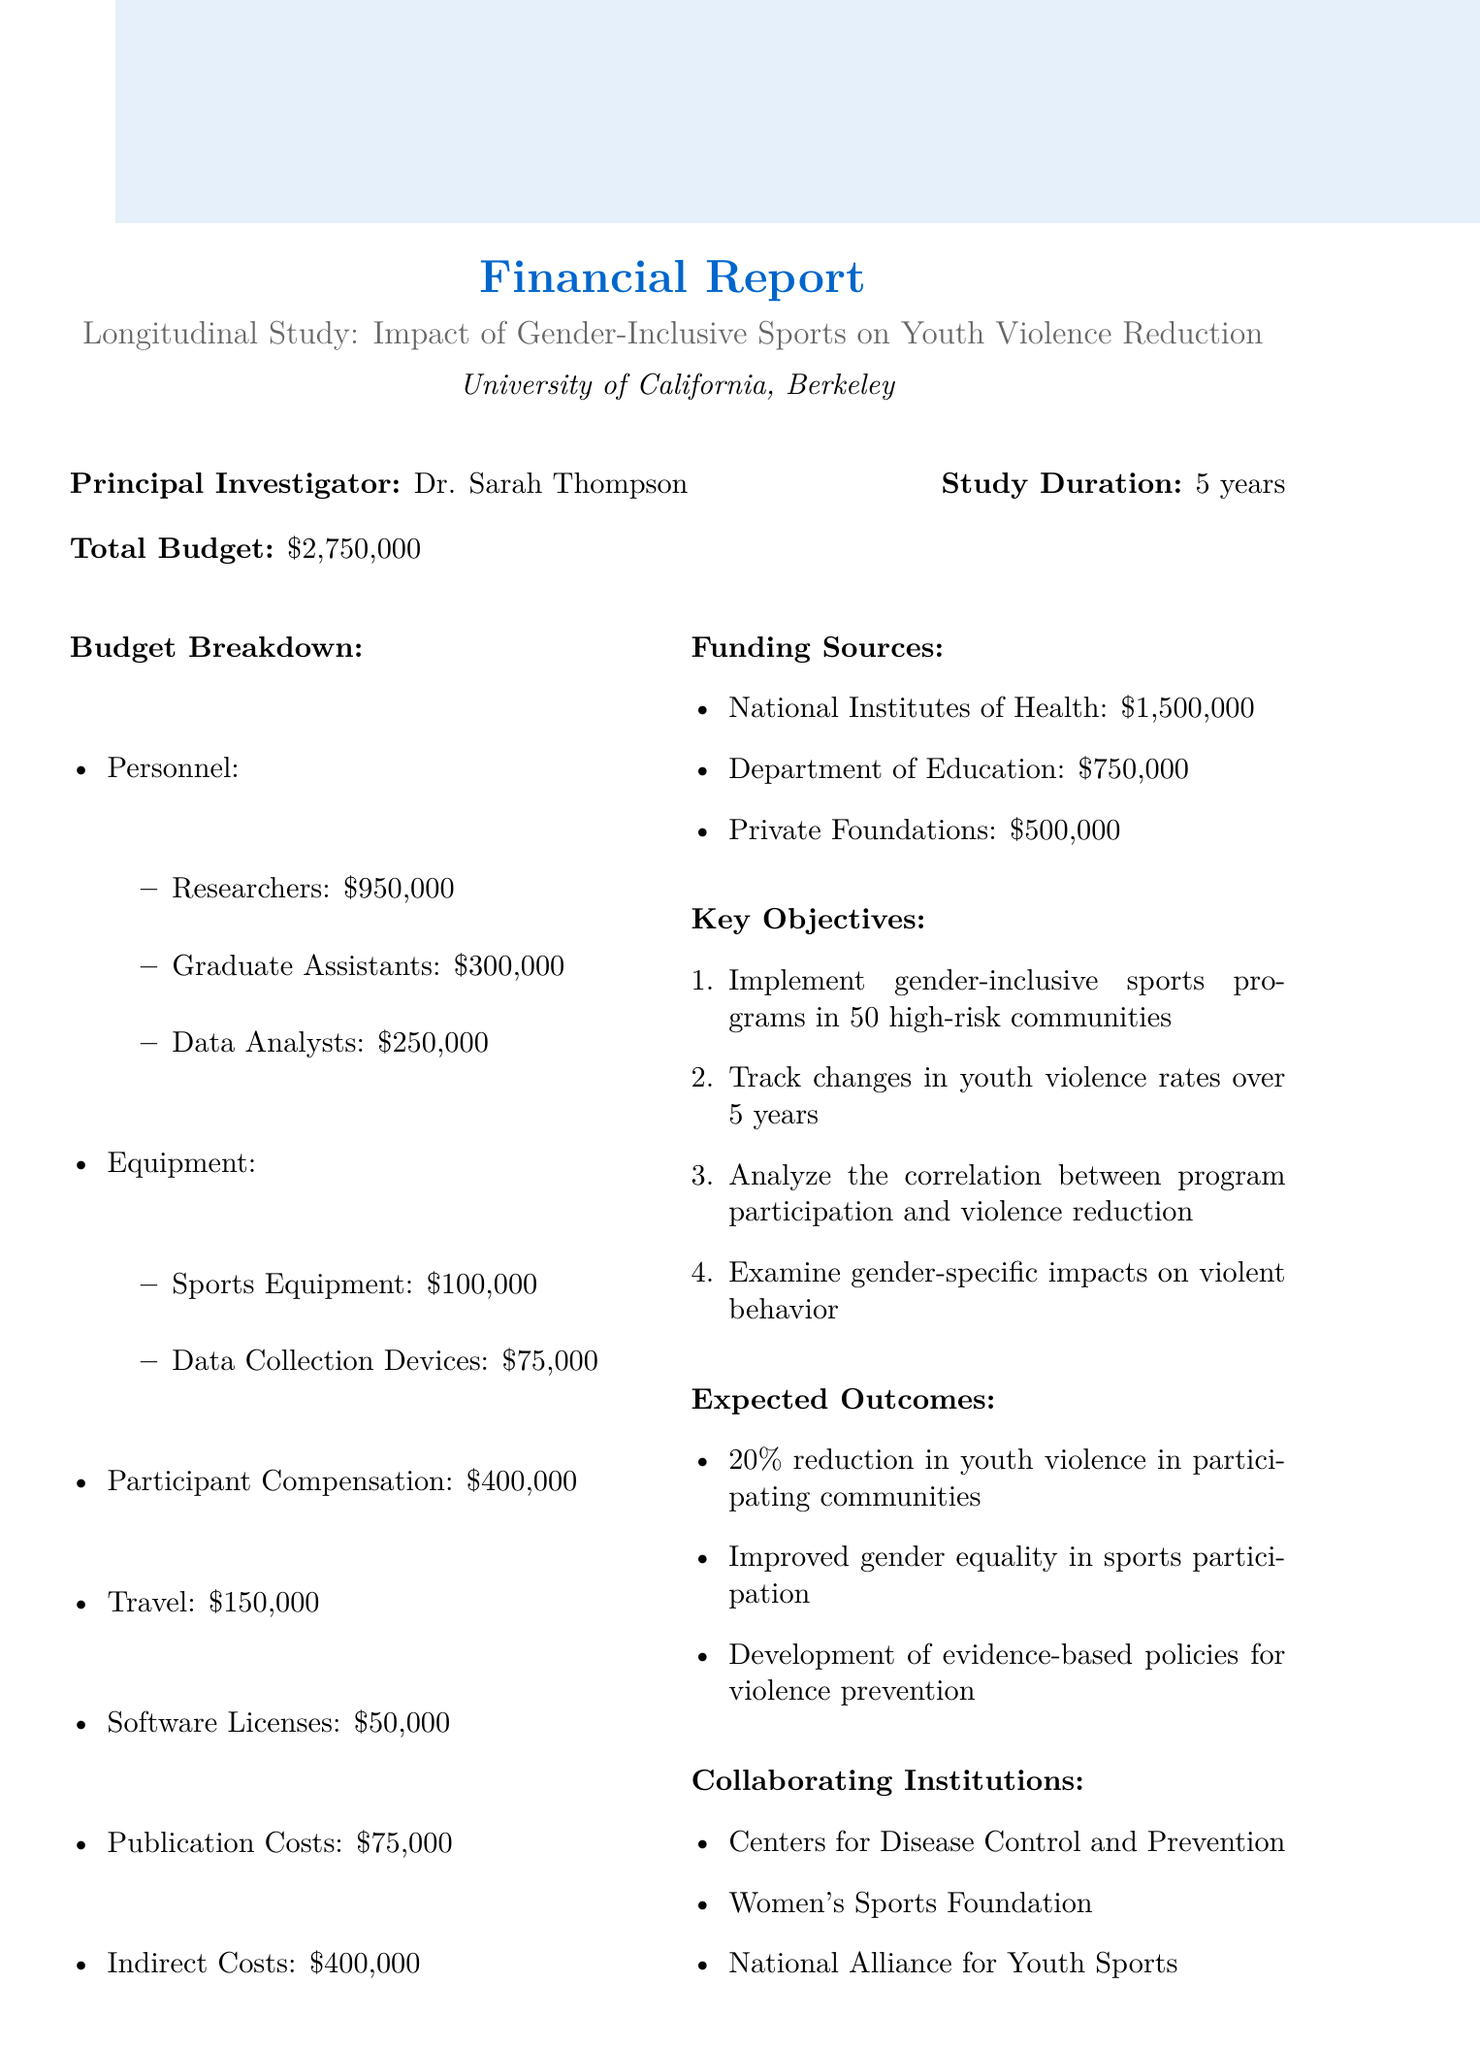What is the total budget? The total budget is listed in the document as a specific amount, which is $2,750,000.
Answer: $2,750,000 Who is the principal investigator? The principal investigator is identified within the document.
Answer: Dr. Sarah Thompson How many high-risk communities will be involved? The document states the number of communities targeted by the program.
Answer: 50 What is the expected percentage reduction in youth violence? The document outlines the expected outcomes, including a specific percentage reduction in violence rates.
Answer: 20% What is the amount allocated for participant compensation? The budget breakdown includes a specific section for participant compensation.
Answer: $400,000 Which funding source contributes the most? The funding sources are listed with their respective amounts, indicating which source is the largest.
Answer: National Institutes of Health How long will the study last? The study duration is explicitly mentioned in the document as a specific time frame.
Answer: 5 years What type of institutions are collaborating with this study? The document lists the types of institutions collaborating on the study.
Answer: Centers for Disease Control and Prevention, Women's Sports Foundation, National Alliance for Youth Sports What will the study analyze regarding program participation? The key objectives include a specific analysis related to program participation and outcomes.
Answer: Correlation between program participation and violence reduction 